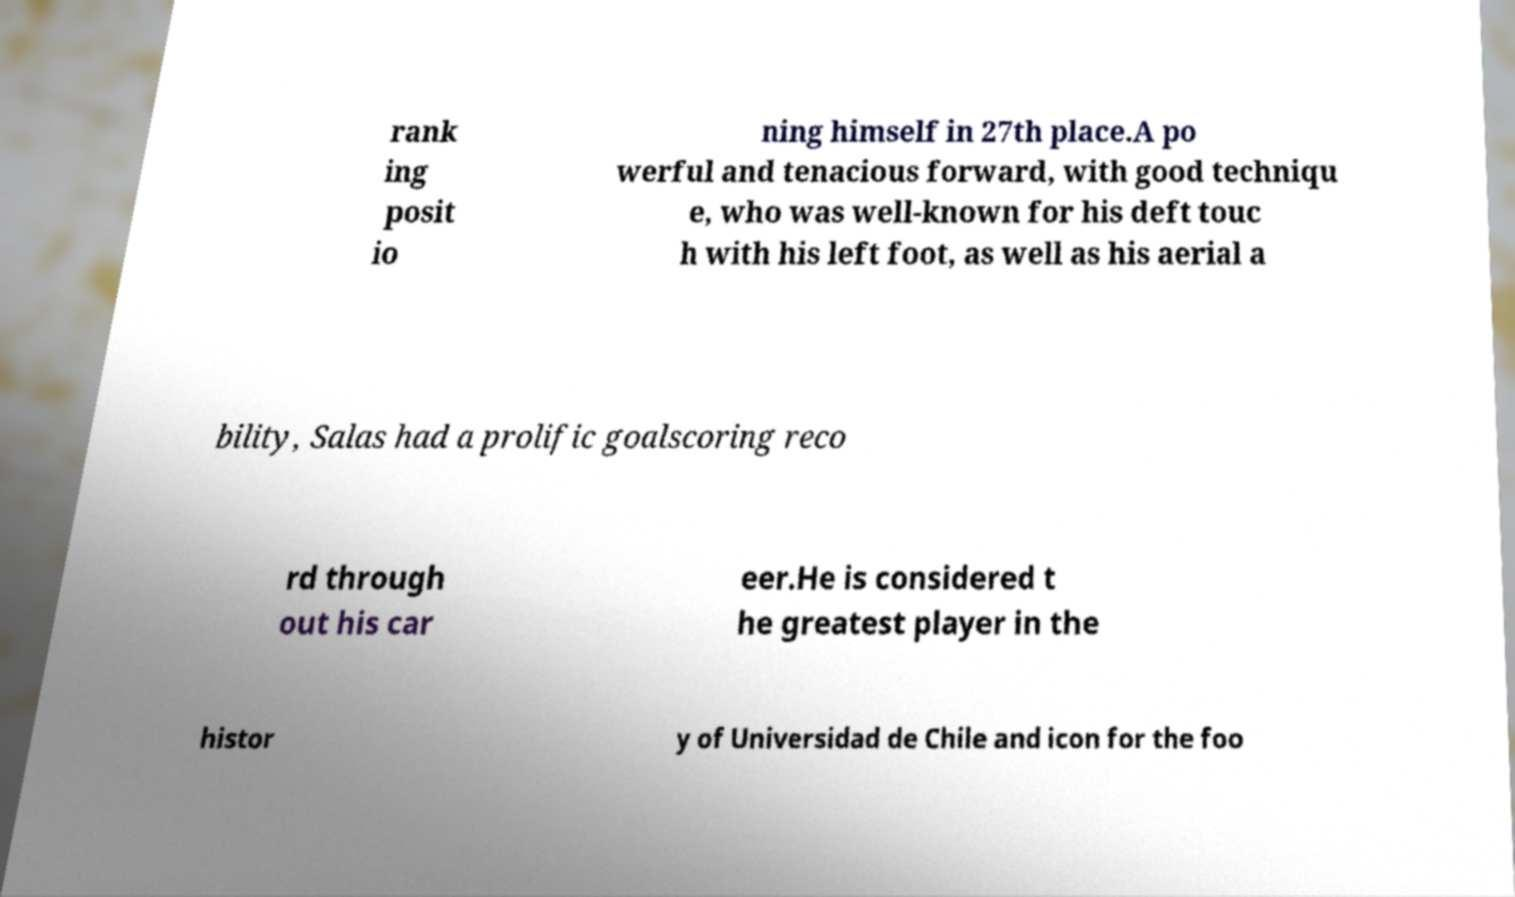Could you extract and type out the text from this image? rank ing posit io ning himself in 27th place.A po werful and tenacious forward, with good techniqu e, who was well-known for his deft touc h with his left foot, as well as his aerial a bility, Salas had a prolific goalscoring reco rd through out his car eer.He is considered t he greatest player in the histor y of Universidad de Chile and icon for the foo 